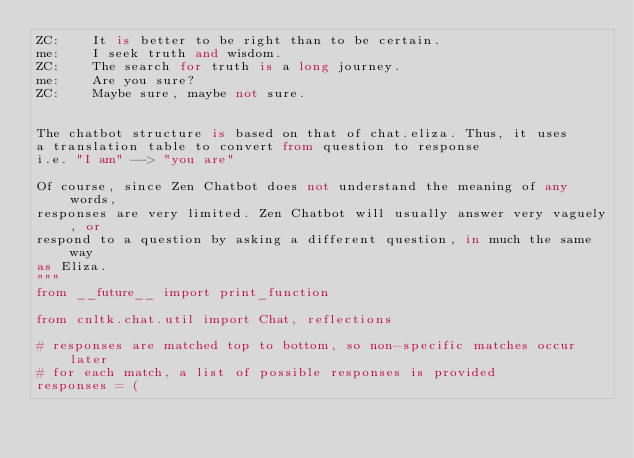<code> <loc_0><loc_0><loc_500><loc_500><_Python_>ZC:    It is better to be right than to be certain.
me:    I seek truth and wisdom.
ZC:    The search for truth is a long journey.
me:    Are you sure?
ZC:    Maybe sure, maybe not sure.


The chatbot structure is based on that of chat.eliza. Thus, it uses
a translation table to convert from question to response
i.e. "I am" --> "you are"

Of course, since Zen Chatbot does not understand the meaning of any words,
responses are very limited. Zen Chatbot will usually answer very vaguely, or
respond to a question by asking a different question, in much the same way
as Eliza.
"""
from __future__ import print_function

from cnltk.chat.util import Chat, reflections

# responses are matched top to bottom, so non-specific matches occur later
# for each match, a list of possible responses is provided
responses = (
</code> 